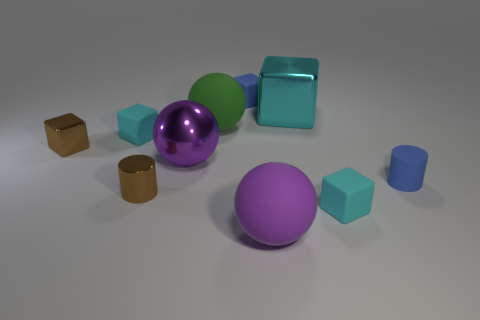How many cyan cubes must be subtracted to get 1 cyan cubes? 2 Subtract all shiny cubes. How many cubes are left? 3 Subtract all blue spheres. How many cyan cubes are left? 3 Subtract all brown cubes. How many cubes are left? 4 Subtract all blue cubes. Subtract all gray cylinders. How many cubes are left? 4 Subtract all cylinders. How many objects are left? 8 Add 8 large purple rubber objects. How many large purple rubber objects exist? 9 Subtract 0 green cylinders. How many objects are left? 10 Subtract all big purple metal spheres. Subtract all rubber cubes. How many objects are left? 6 Add 6 large purple rubber spheres. How many large purple rubber spheres are left? 7 